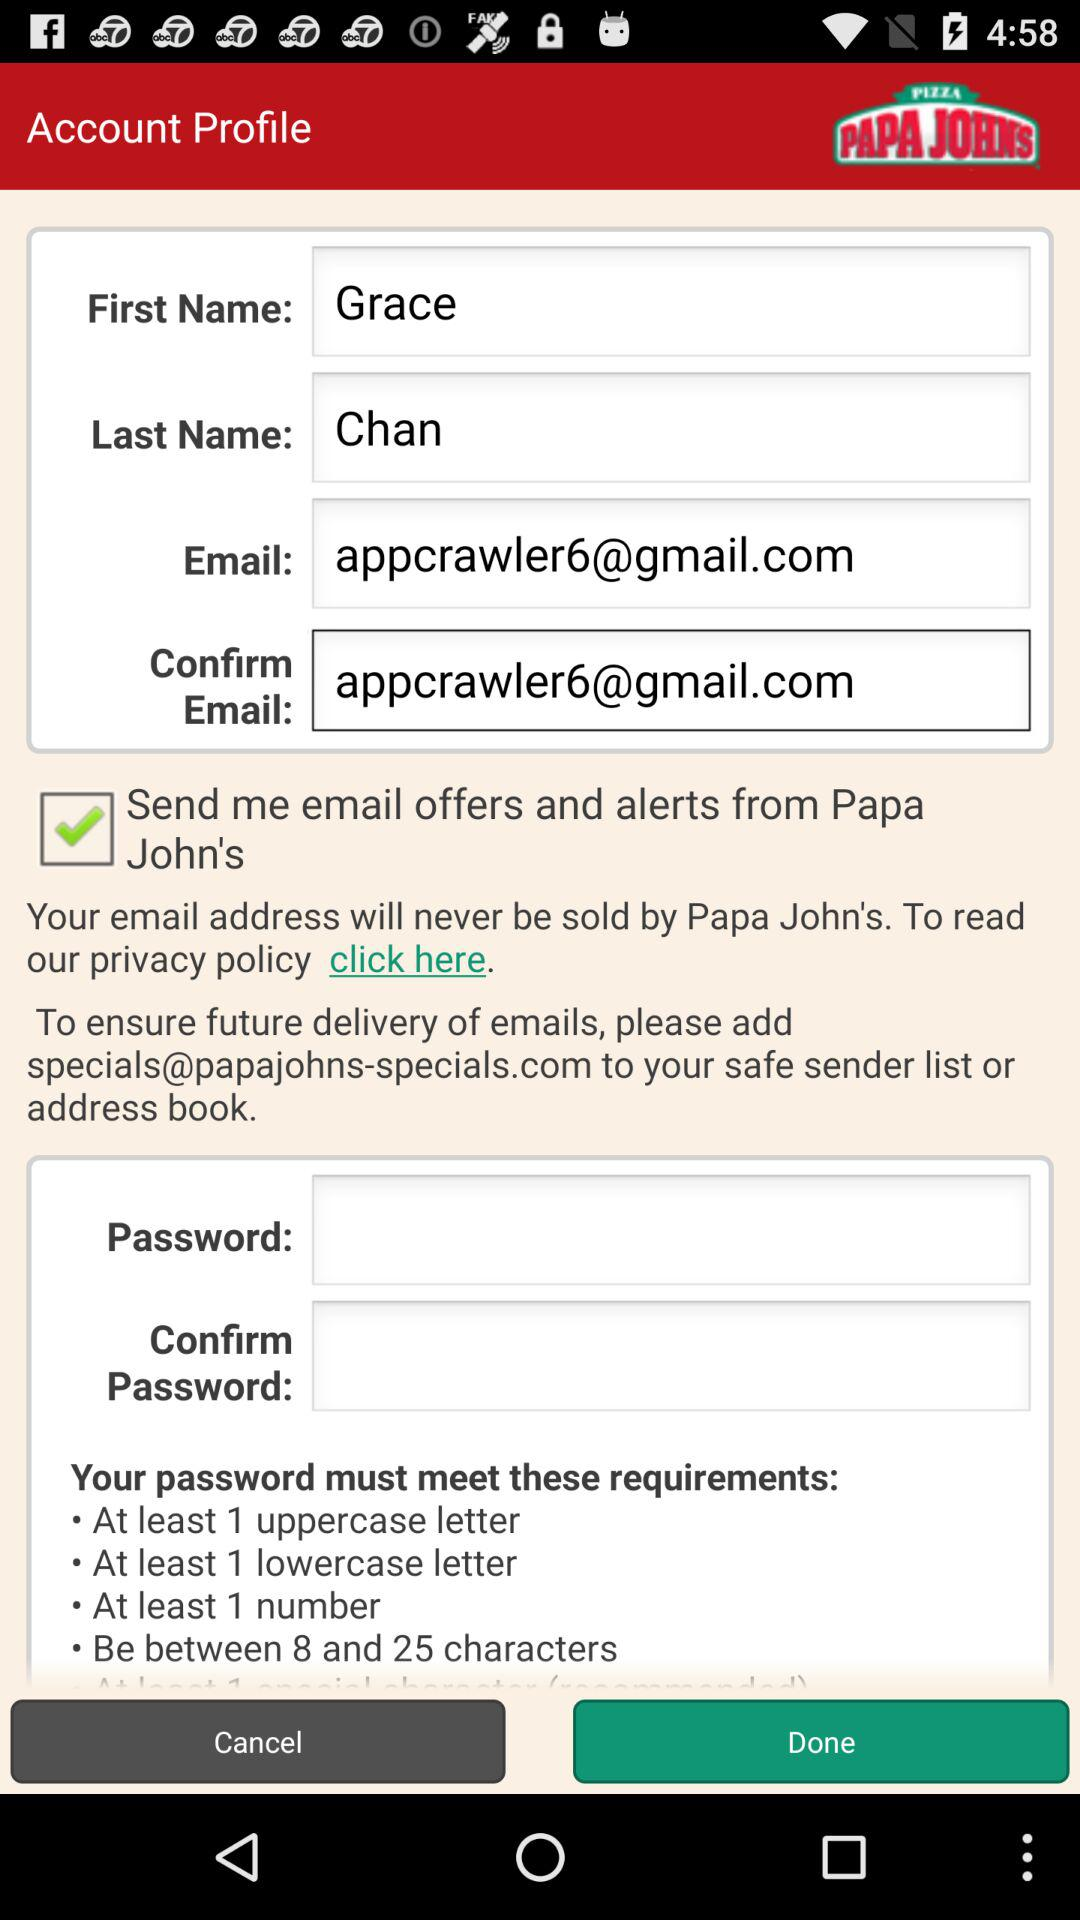What is the minimum number required in your password? The password must contain at least one number. 